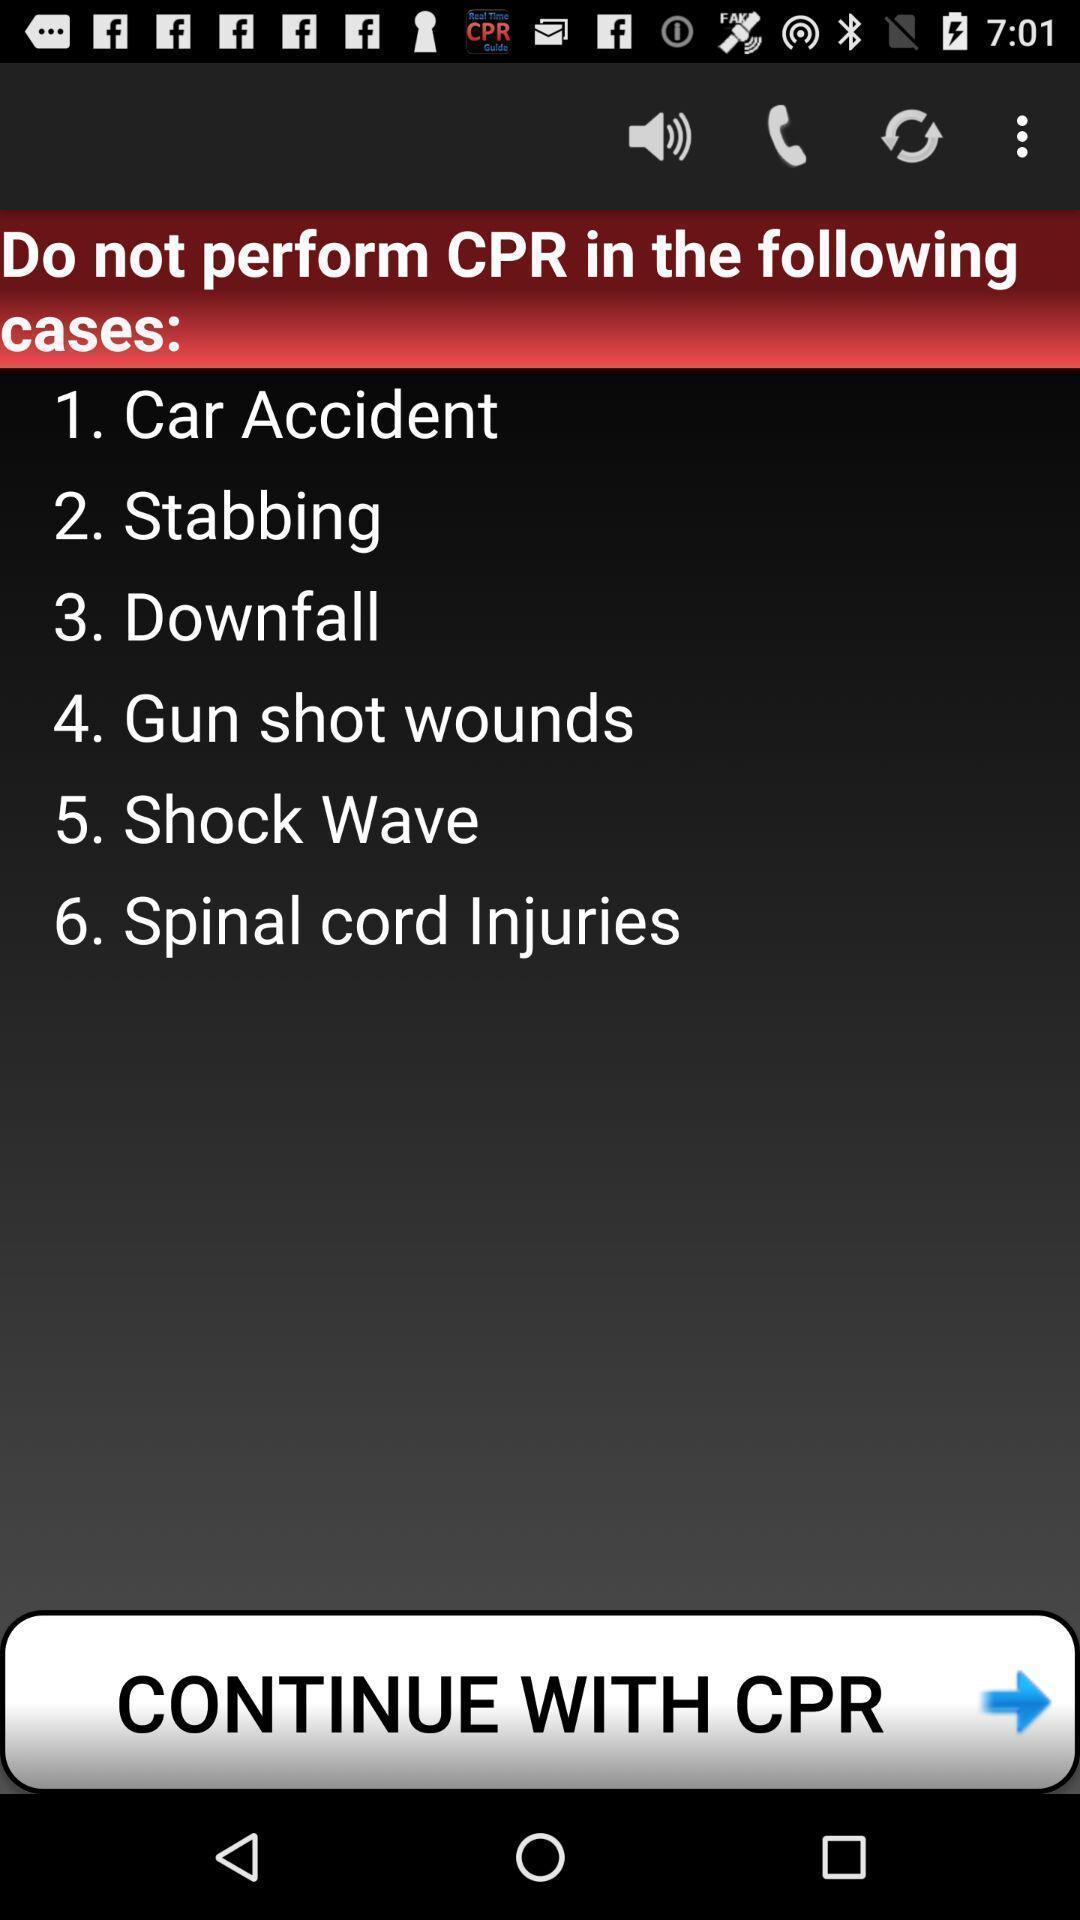Summarize the main components in this picture. Screen shows list of cases. 